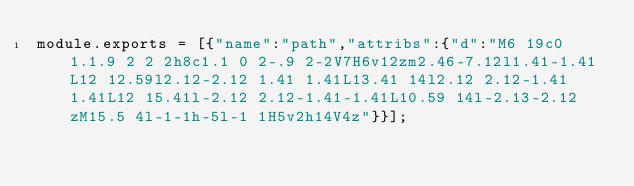Convert code to text. <code><loc_0><loc_0><loc_500><loc_500><_JavaScript_>module.exports = [{"name":"path","attribs":{"d":"M6 19c0 1.1.9 2 2 2h8c1.1 0 2-.9 2-2V7H6v12zm2.46-7.12l1.41-1.41L12 12.59l2.12-2.12 1.41 1.41L13.41 14l2.12 2.12-1.41 1.41L12 15.41l-2.12 2.12-1.41-1.41L10.59 14l-2.13-2.12zM15.5 4l-1-1h-5l-1 1H5v2h14V4z"}}];</code> 